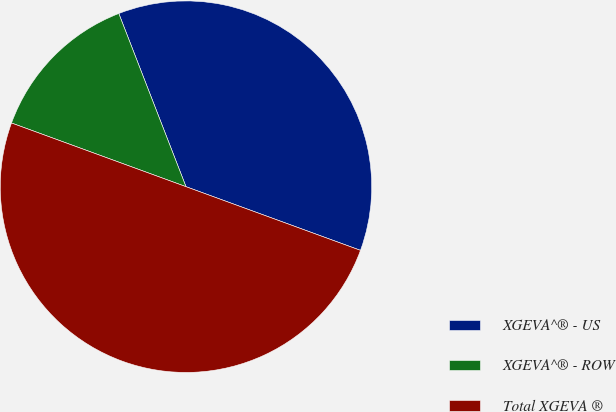Convert chart to OTSL. <chart><loc_0><loc_0><loc_500><loc_500><pie_chart><fcel>XGEVA^® - US<fcel>XGEVA^® - ROW<fcel>Total XGEVA ®<nl><fcel>36.46%<fcel>13.54%<fcel>50.0%<nl></chart> 